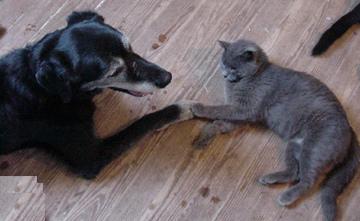What color is the cat?
Quick response, please. Gray. What animals are these?
Short answer required. Cat and dog. What is the main color of the dog?
Be succinct. Black. Are these animals friends?
Quick response, please. Yes. 